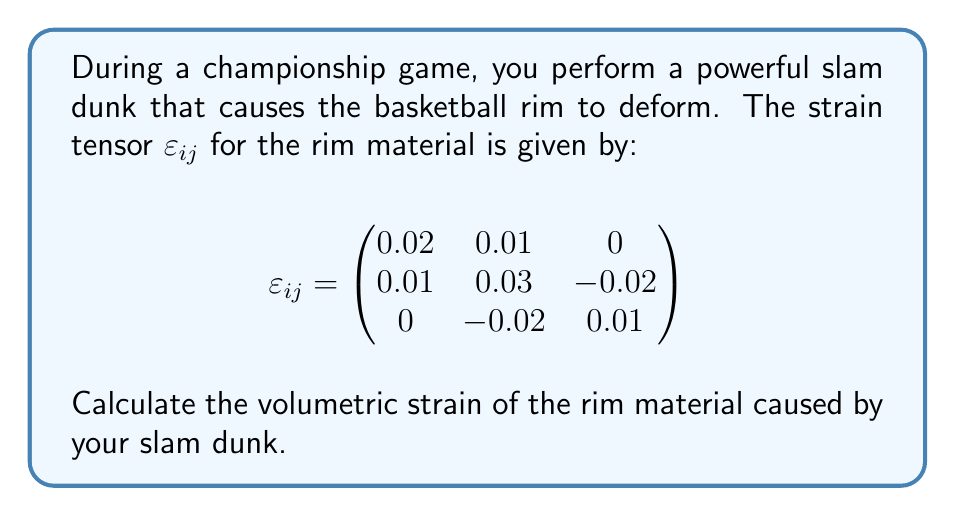Solve this math problem. To solve this problem, we'll follow these steps:

1) The volumetric strain is defined as the trace of the strain tensor. In tensor notation, this is:

   $$\varepsilon_v = \text{tr}(\varepsilon_{ij}) = \varepsilon_{11} + \varepsilon_{22} + \varepsilon_{33}$$

2) From the given strain tensor, we can identify:
   
   $\varepsilon_{11} = 0.02$
   $\varepsilon_{22} = 0.03$
   $\varepsilon_{33} = 0.01$

3) Now, we simply sum these diagonal elements:

   $$\varepsilon_v = 0.02 + 0.03 + 0.01$$

4) Calculating the sum:

   $$\varepsilon_v = 0.06$$

5) Therefore, the volumetric strain is 0.06 or 6%.

This means that the volume of the rim material has increased by 6% due to the deformation caused by the slam dunk.
Answer: 0.06 